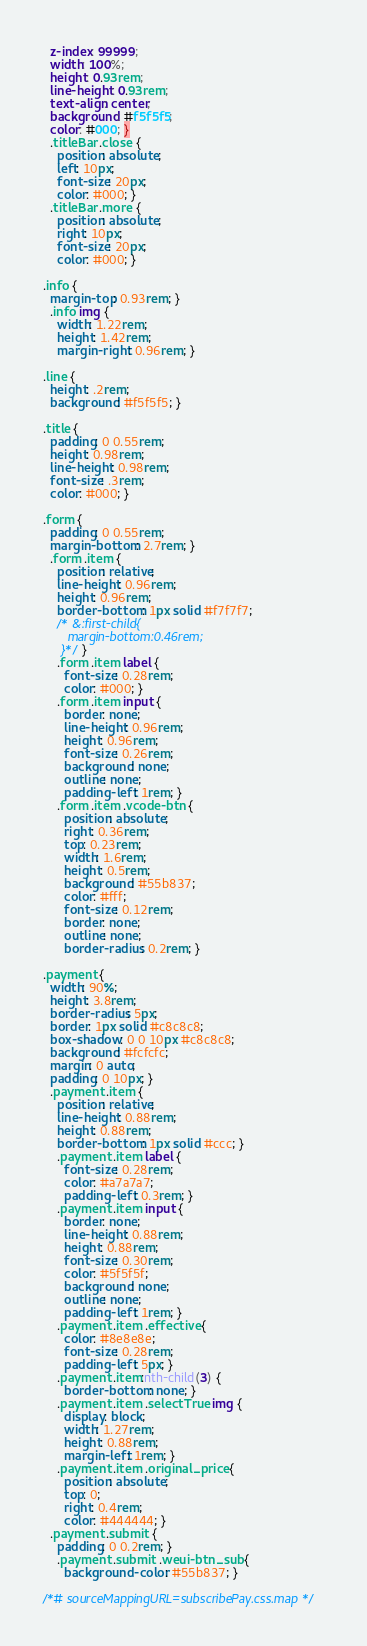<code> <loc_0><loc_0><loc_500><loc_500><_CSS_>  z-index: 99999;
  width: 100%;
  height: 0.93rem;
  line-height: 0.93rem;
  text-align: center;
  background: #f5f5f5;
  color: #000; }
  .titleBar .close {
    position: absolute;
    left: 10px;
    font-size: 20px;
    color: #000; }
  .titleBar .more {
    position: absolute;
    right: 10px;
    font-size: 20px;
    color: #000; }

.info {
  margin-top: 0.93rem; }
  .info img {
    width: 1.22rem;
    height: 1.42rem;
    margin-right: 0.96rem; }

.line {
  height: .2rem;
  background: #f5f5f5; }

.title {
  padding: 0 0.55rem;
  height: 0.98rem;
  line-height: 0.98rem;
  font-size: .3rem;
  color: #000; }

.form {
  padding: 0 0.55rem;
  margin-bottom: 2.7rem; }
  .form .item {
    position: relative;
    line-height: 0.96rem;
    height: 0.96rem;
    border-bottom: 1px solid #f7f7f7;
    /* &:first-child{
       margin-bottom:0.46rem;
     }*/ }
    .form .item label {
      font-size: 0.28rem;
      color: #000; }
    .form .item input {
      border: none;
      line-height: 0.96rem;
      height: 0.96rem;
      font-size: 0.26rem;
      background: none;
      outline: none;
      padding-left: 1rem; }
    .form .item .vcode-btn {
      position: absolute;
      right: 0.36rem;
      top: 0.23rem;
      width: 1.6rem;
      height: 0.5rem;
      background: #55b837;
      color: #fff;
      font-size: 0.12rem;
      border: none;
      outline: none;
      border-radius: 0.2rem; }

.payment {
  width: 90%;
  height: 3.8rem;
  border-radius: 5px;
  border: 1px solid #c8c8c8;
  box-shadow: 0 0 10px #c8c8c8;
  background: #fcfcfc;
  margin: 0 auto;
  padding: 0 10px; }
  .payment .item {
    position: relative;
    line-height: 0.88rem;
    height: 0.88rem;
    border-bottom: 1px solid #ccc; }
    .payment .item label {
      font-size: 0.28rem;
      color: #a7a7a7;
      padding-left: 0.3rem; }
    .payment .item input {
      border: none;
      line-height: 0.88rem;
      height: 0.88rem;
      font-size: 0.30rem;
      color: #5f5f5f;
      background: none;
      outline: none;
      padding-left: 1rem; }
    .payment .item .effective {
      color: #8e8e8e;
      font-size: 0.28rem;
      padding-left: 5px; }
    .payment .item:nth-child(3) {
      border-bottom: none; }
    .payment .item .selectTrue img {
      display: block;
      width: 1.27rem;
      height: 0.88rem;
      margin-left: 1rem; }
    .payment .item .original_price {
      position: absolute;
      top: 0;
      right: 0.4rem;
      color: #444444; }
  .payment .submit {
    padding: 0 0.2rem; }
    .payment .submit .weui-btn_sub {
      background-color: #55b837; }

/*# sourceMappingURL=subscribePay.css.map */
</code> 